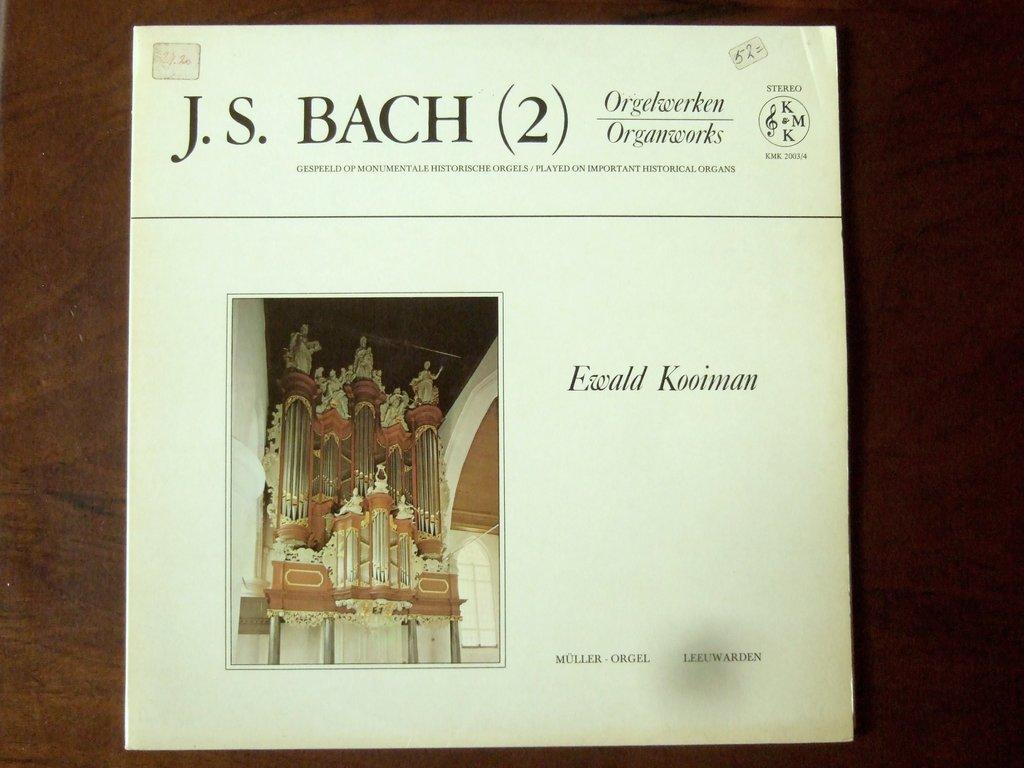Who is the composer?
Provide a succinct answer. J.s. bach. What number is in parenthesis on the top of the page?
Ensure brevity in your answer.  2. 